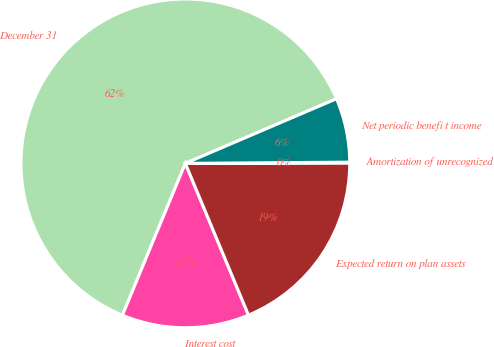Convert chart. <chart><loc_0><loc_0><loc_500><loc_500><pie_chart><fcel>December 31<fcel>Interest cost<fcel>Expected return on plan assets<fcel>Amortization of unrecognized<fcel>Net periodic benefi t income<nl><fcel>62.32%<fcel>12.53%<fcel>18.76%<fcel>0.08%<fcel>6.31%<nl></chart> 